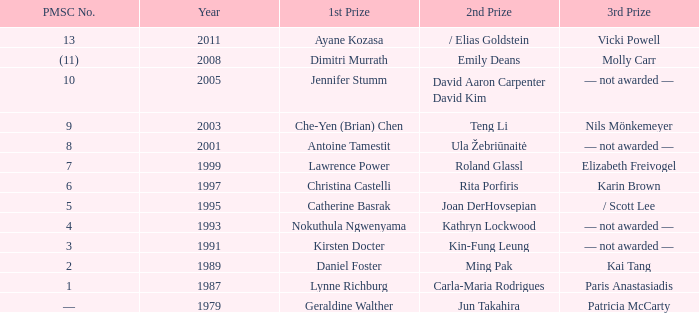In what year did Kin-fung Leung get 2nd prize? 1991.0. 